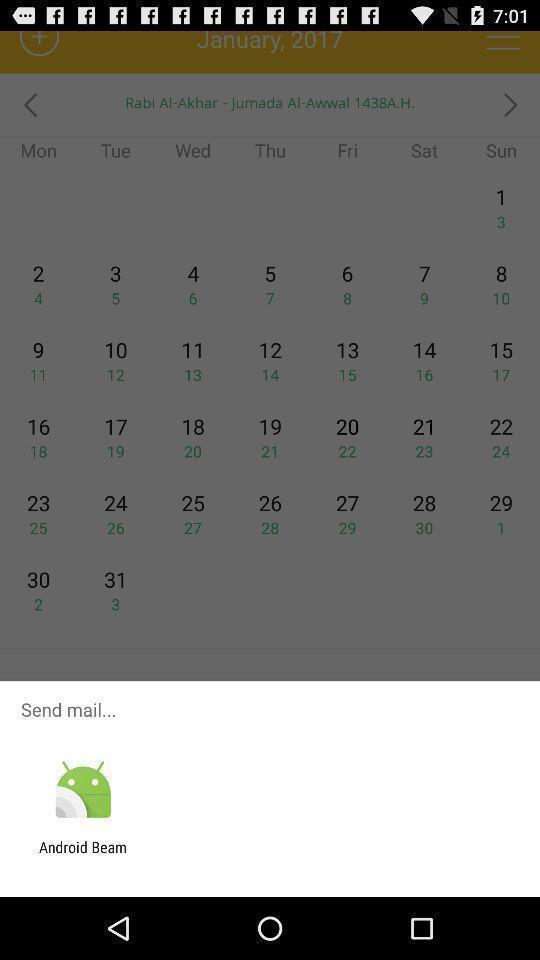What can you discern from this picture? Send mail through the app. 